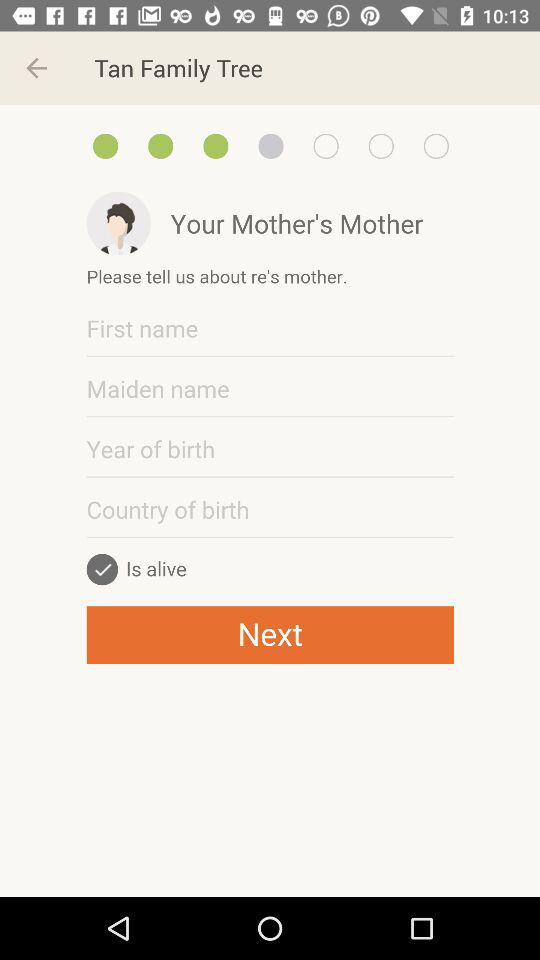What is the status of the alive? The status is on. 